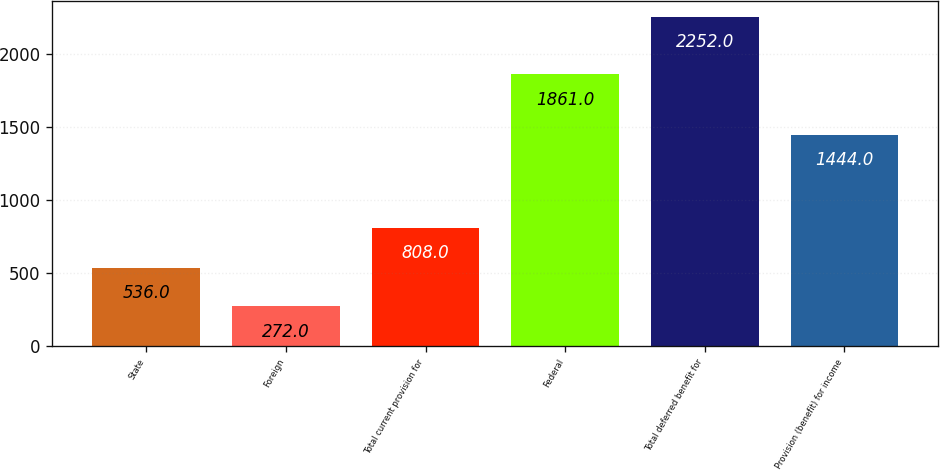<chart> <loc_0><loc_0><loc_500><loc_500><bar_chart><fcel>State<fcel>Foreign<fcel>Total current provision for<fcel>Federal<fcel>Total deferred benefit for<fcel>Provision (benefit) for income<nl><fcel>536<fcel>272<fcel>808<fcel>1861<fcel>2252<fcel>1444<nl></chart> 